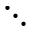<formula> <loc_0><loc_0><loc_500><loc_500>\ddots</formula> 